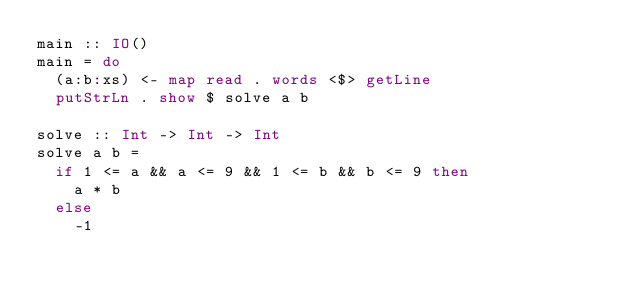Convert code to text. <code><loc_0><loc_0><loc_500><loc_500><_Haskell_>main :: IO()
main = do
  (a:b:xs) <- map read . words <$> getLine
  putStrLn . show $ solve a b

solve :: Int -> Int -> Int
solve a b = 
  if 1 <= a && a <= 9 && 1 <= b && b <= 9 then   
    a * b
  else
    -1</code> 